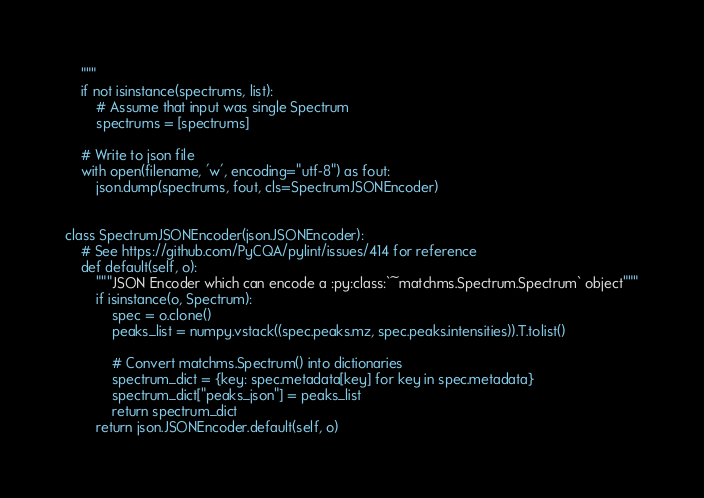<code> <loc_0><loc_0><loc_500><loc_500><_Python_>    """
    if not isinstance(spectrums, list):
        # Assume that input was single Spectrum
        spectrums = [spectrums]

    # Write to json file
    with open(filename, 'w', encoding="utf-8") as fout:
        json.dump(spectrums, fout, cls=SpectrumJSONEncoder)


class SpectrumJSONEncoder(json.JSONEncoder):
    # See https://github.com/PyCQA/pylint/issues/414 for reference
    def default(self, o):
        """JSON Encoder which can encode a :py:class:`~matchms.Spectrum.Spectrum` object"""
        if isinstance(o, Spectrum):
            spec = o.clone()
            peaks_list = numpy.vstack((spec.peaks.mz, spec.peaks.intensities)).T.tolist()

            # Convert matchms.Spectrum() into dictionaries
            spectrum_dict = {key: spec.metadata[key] for key in spec.metadata}
            spectrum_dict["peaks_json"] = peaks_list
            return spectrum_dict
        return json.JSONEncoder.default(self, o)
</code> 